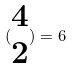<formula> <loc_0><loc_0><loc_500><loc_500>( \begin{matrix} 4 \\ 2 \end{matrix} ) = 6</formula> 